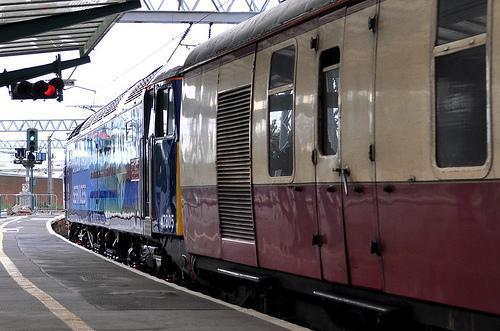How many cars are shown?
Give a very brief answer. 2. 